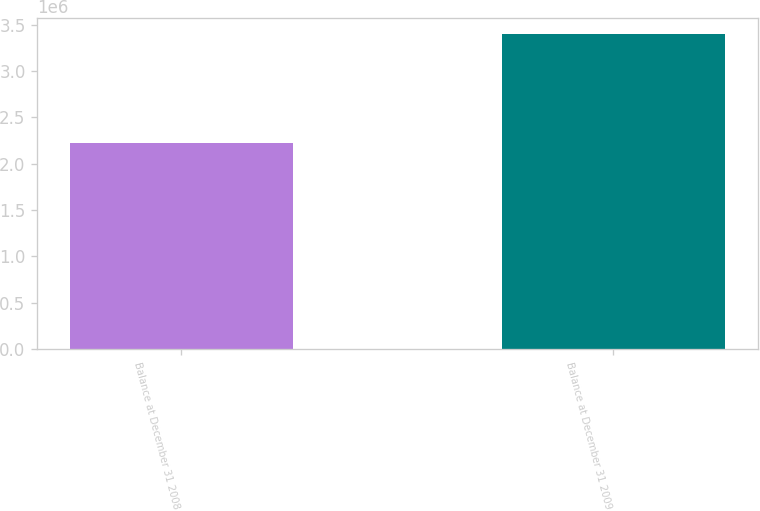<chart> <loc_0><loc_0><loc_500><loc_500><bar_chart><fcel>Balance at December 31 2008<fcel>Balance at December 31 2009<nl><fcel>2.22291e+06<fcel>3.39889e+06<nl></chart> 